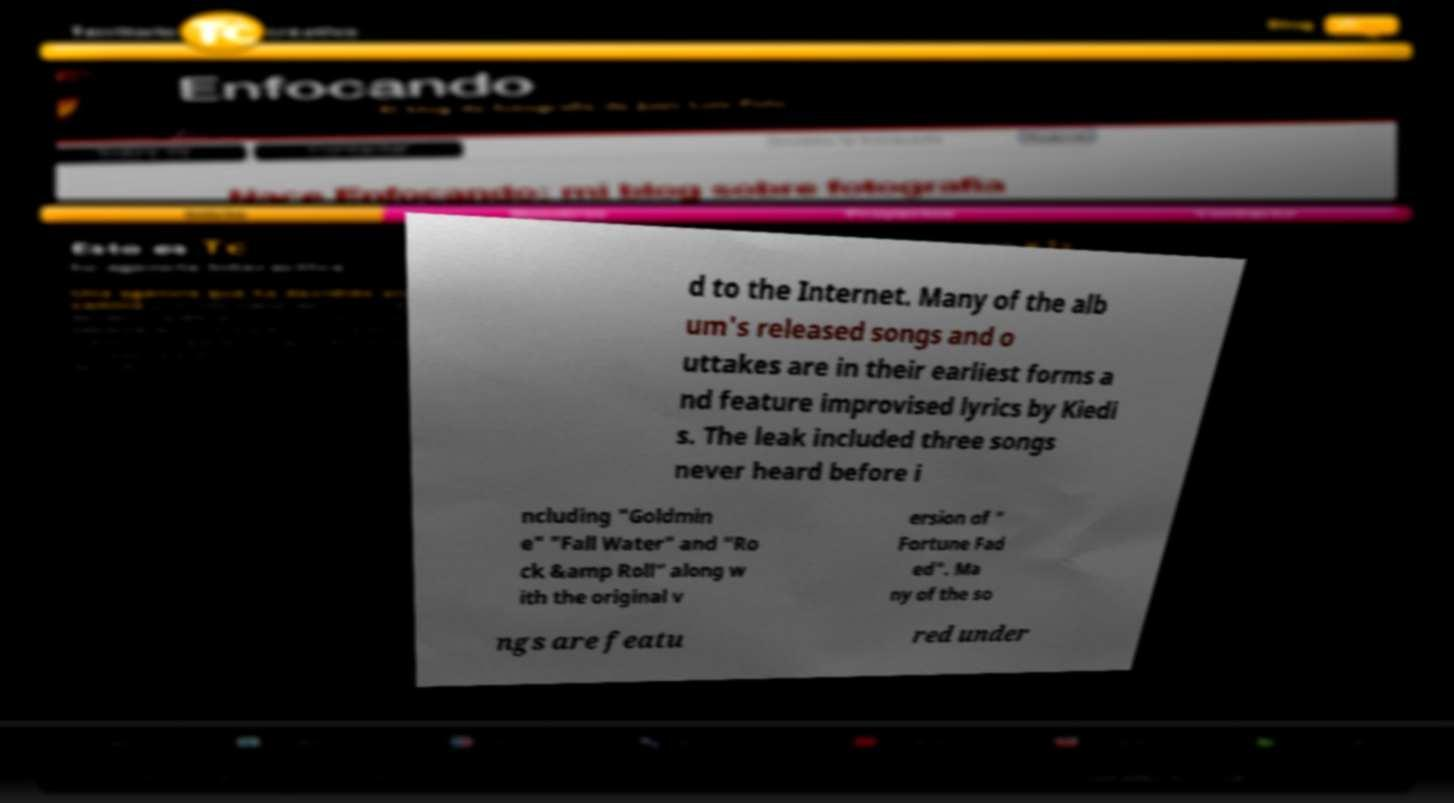Please identify and transcribe the text found in this image. d to the Internet. Many of the alb um's released songs and o uttakes are in their earliest forms a nd feature improvised lyrics by Kiedi s. The leak included three songs never heard before i ncluding "Goldmin e" "Fall Water" and "Ro ck &amp Roll" along w ith the original v ersion of " Fortune Fad ed". Ma ny of the so ngs are featu red under 